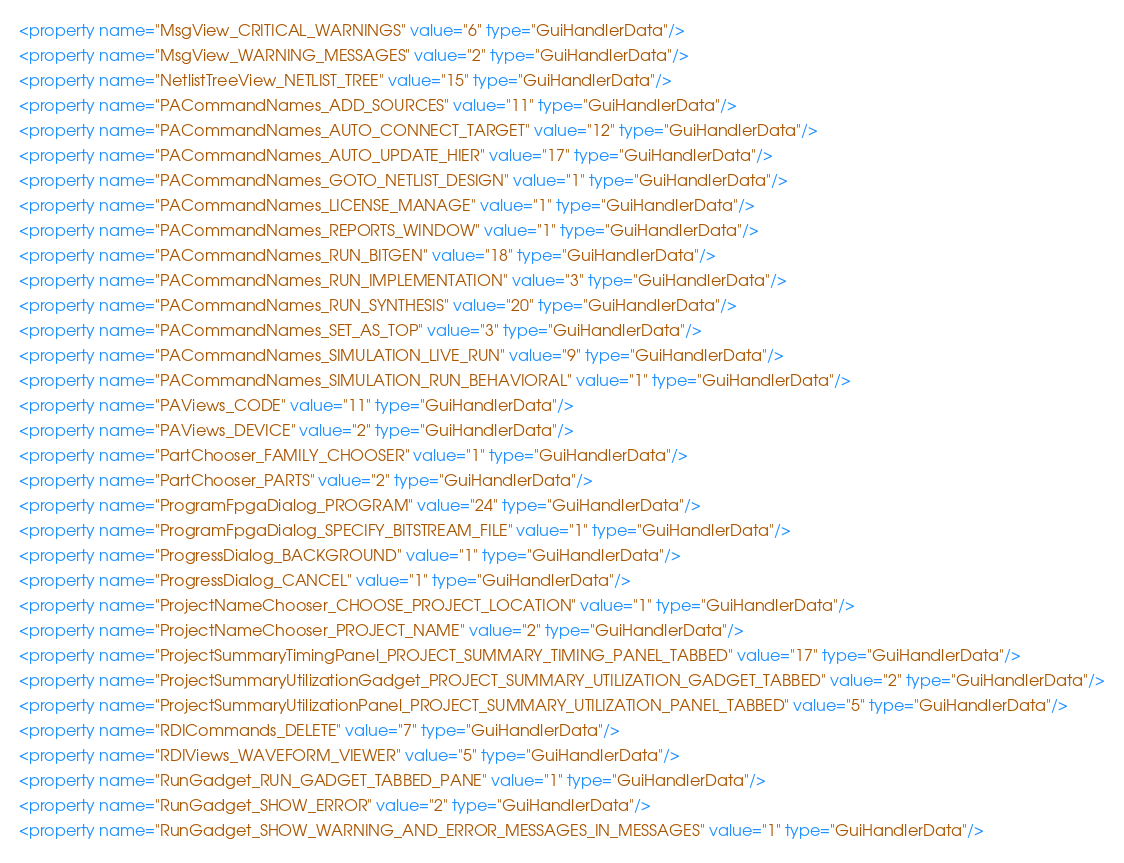<code> <loc_0><loc_0><loc_500><loc_500><_XML_><property name="MsgView_CRITICAL_WARNINGS" value="6" type="GuiHandlerData"/>
<property name="MsgView_WARNING_MESSAGES" value="2" type="GuiHandlerData"/>
<property name="NetlistTreeView_NETLIST_TREE" value="15" type="GuiHandlerData"/>
<property name="PACommandNames_ADD_SOURCES" value="11" type="GuiHandlerData"/>
<property name="PACommandNames_AUTO_CONNECT_TARGET" value="12" type="GuiHandlerData"/>
<property name="PACommandNames_AUTO_UPDATE_HIER" value="17" type="GuiHandlerData"/>
<property name="PACommandNames_GOTO_NETLIST_DESIGN" value="1" type="GuiHandlerData"/>
<property name="PACommandNames_LICENSE_MANAGE" value="1" type="GuiHandlerData"/>
<property name="PACommandNames_REPORTS_WINDOW" value="1" type="GuiHandlerData"/>
<property name="PACommandNames_RUN_BITGEN" value="18" type="GuiHandlerData"/>
<property name="PACommandNames_RUN_IMPLEMENTATION" value="3" type="GuiHandlerData"/>
<property name="PACommandNames_RUN_SYNTHESIS" value="20" type="GuiHandlerData"/>
<property name="PACommandNames_SET_AS_TOP" value="3" type="GuiHandlerData"/>
<property name="PACommandNames_SIMULATION_LIVE_RUN" value="9" type="GuiHandlerData"/>
<property name="PACommandNames_SIMULATION_RUN_BEHAVIORAL" value="1" type="GuiHandlerData"/>
<property name="PAViews_CODE" value="11" type="GuiHandlerData"/>
<property name="PAViews_DEVICE" value="2" type="GuiHandlerData"/>
<property name="PartChooser_FAMILY_CHOOSER" value="1" type="GuiHandlerData"/>
<property name="PartChooser_PARTS" value="2" type="GuiHandlerData"/>
<property name="ProgramFpgaDialog_PROGRAM" value="24" type="GuiHandlerData"/>
<property name="ProgramFpgaDialog_SPECIFY_BITSTREAM_FILE" value="1" type="GuiHandlerData"/>
<property name="ProgressDialog_BACKGROUND" value="1" type="GuiHandlerData"/>
<property name="ProgressDialog_CANCEL" value="1" type="GuiHandlerData"/>
<property name="ProjectNameChooser_CHOOSE_PROJECT_LOCATION" value="1" type="GuiHandlerData"/>
<property name="ProjectNameChooser_PROJECT_NAME" value="2" type="GuiHandlerData"/>
<property name="ProjectSummaryTimingPanel_PROJECT_SUMMARY_TIMING_PANEL_TABBED" value="17" type="GuiHandlerData"/>
<property name="ProjectSummaryUtilizationGadget_PROJECT_SUMMARY_UTILIZATION_GADGET_TABBED" value="2" type="GuiHandlerData"/>
<property name="ProjectSummaryUtilizationPanel_PROJECT_SUMMARY_UTILIZATION_PANEL_TABBED" value="5" type="GuiHandlerData"/>
<property name="RDICommands_DELETE" value="7" type="GuiHandlerData"/>
<property name="RDIViews_WAVEFORM_VIEWER" value="5" type="GuiHandlerData"/>
<property name="RunGadget_RUN_GADGET_TABBED_PANE" value="1" type="GuiHandlerData"/>
<property name="RunGadget_SHOW_ERROR" value="2" type="GuiHandlerData"/>
<property name="RunGadget_SHOW_WARNING_AND_ERROR_MESSAGES_IN_MESSAGES" value="1" type="GuiHandlerData"/></code> 